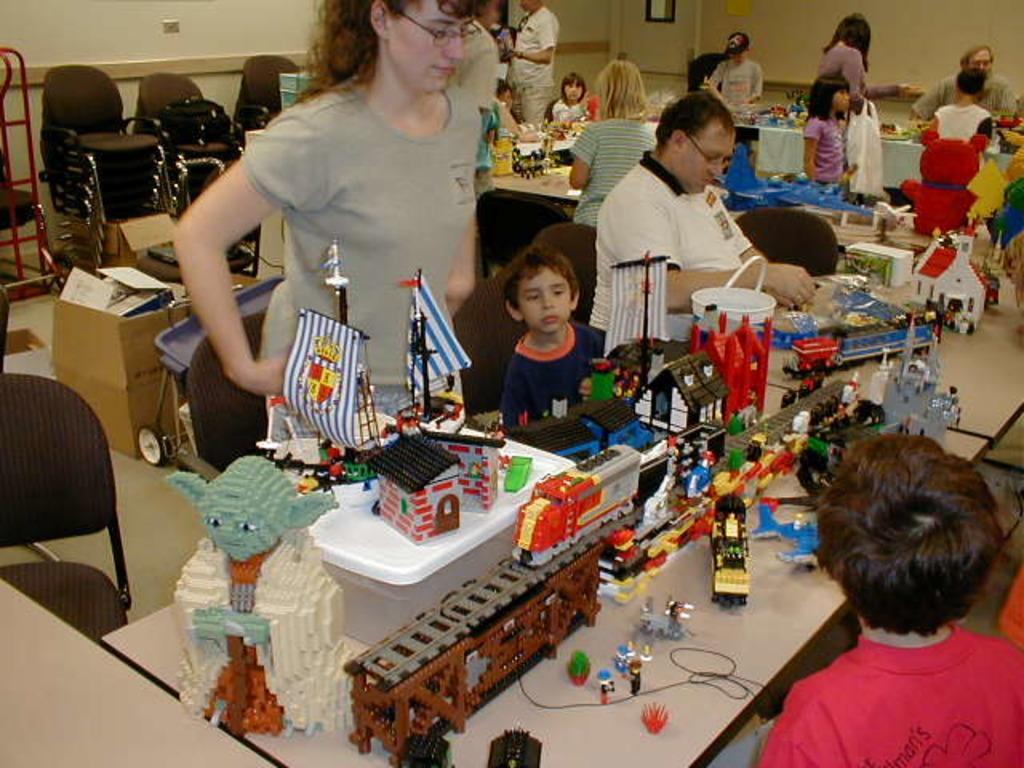Describe this image in one or two sentences. In this image i can see few persons standing and few persons sitting, there are few toys on a table at the back ground i can see few cart boards, chairs and a wall. 